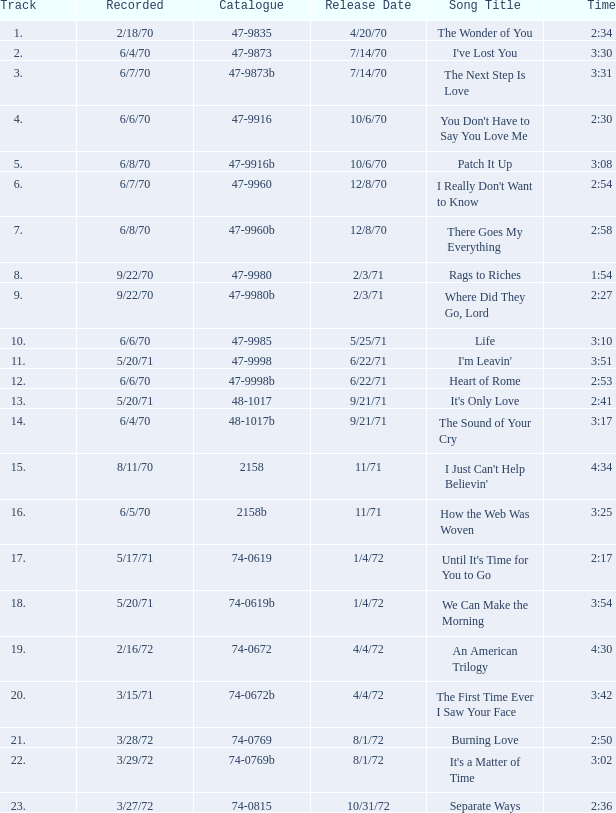Parse the full table. {'header': ['Track', 'Recorded', 'Catalogue', 'Release Date', 'Song Title', 'Time'], 'rows': [['1.', '2/18/70', '47-9835', '4/20/70', 'The Wonder of You', '2:34'], ['2.', '6/4/70', '47-9873', '7/14/70', "I've Lost You", '3:30'], ['3.', '6/7/70', '47-9873b', '7/14/70', 'The Next Step Is Love', '3:31'], ['4.', '6/6/70', '47-9916', '10/6/70', "You Don't Have to Say You Love Me", '2:30'], ['5.', '6/8/70', '47-9916b', '10/6/70', 'Patch It Up', '3:08'], ['6.', '6/7/70', '47-9960', '12/8/70', "I Really Don't Want to Know", '2:54'], ['7.', '6/8/70', '47-9960b', '12/8/70', 'There Goes My Everything', '2:58'], ['8.', '9/22/70', '47-9980', '2/3/71', 'Rags to Riches', '1:54'], ['9.', '9/22/70', '47-9980b', '2/3/71', 'Where Did They Go, Lord', '2:27'], ['10.', '6/6/70', '47-9985', '5/25/71', 'Life', '3:10'], ['11.', '5/20/71', '47-9998', '6/22/71', "I'm Leavin'", '3:51'], ['12.', '6/6/70', '47-9998b', '6/22/71', 'Heart of Rome', '2:53'], ['13.', '5/20/71', '48-1017', '9/21/71', "It's Only Love", '2:41'], ['14.', '6/4/70', '48-1017b', '9/21/71', 'The Sound of Your Cry', '3:17'], ['15.', '8/11/70', '2158', '11/71', "I Just Can't Help Believin'", '4:34'], ['16.', '6/5/70', '2158b', '11/71', 'How the Web Was Woven', '3:25'], ['17.', '5/17/71', '74-0619', '1/4/72', "Until It's Time for You to Go", '2:17'], ['18.', '5/20/71', '74-0619b', '1/4/72', 'We Can Make the Morning', '3:54'], ['19.', '2/16/72', '74-0672', '4/4/72', 'An American Trilogy', '4:30'], ['20.', '3/15/71', '74-0672b', '4/4/72', 'The First Time Ever I Saw Your Face', '3:42'], ['21.', '3/28/72', '74-0769', '8/1/72', 'Burning Love', '2:50'], ['22.', '3/29/72', '74-0769b', '8/1/72', "It's a Matter of Time", '3:02'], ['23.', '3/27/72', '74-0815', '10/31/72', 'Separate Ways', '2:36']]} What is the reference number for heart of rome? 47-9998b. 